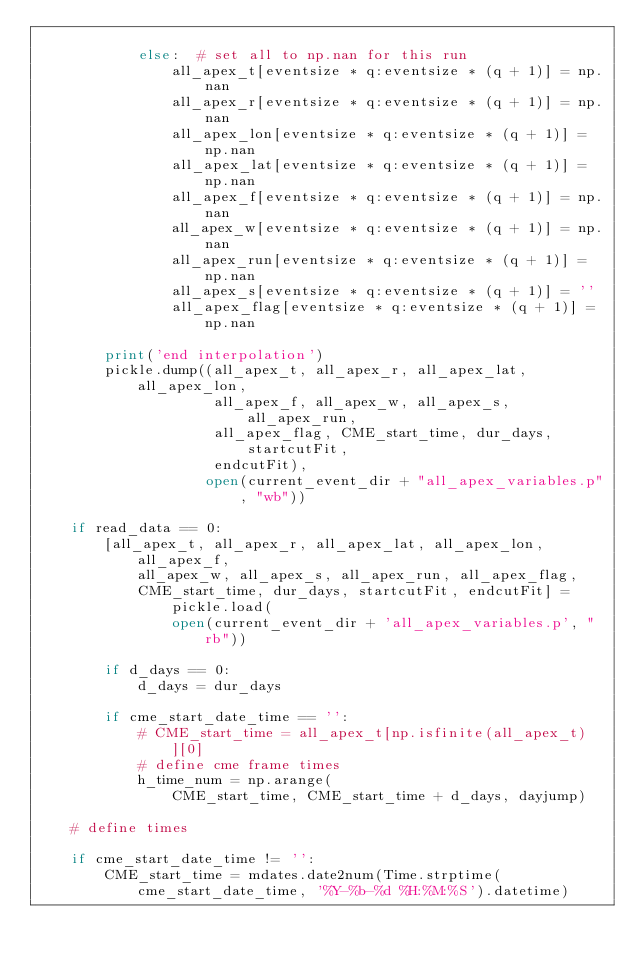<code> <loc_0><loc_0><loc_500><loc_500><_Python_>
            else:  # set all to np.nan for this run
                all_apex_t[eventsize * q:eventsize * (q + 1)] = np.nan
                all_apex_r[eventsize * q:eventsize * (q + 1)] = np.nan
                all_apex_lon[eventsize * q:eventsize * (q + 1)] = np.nan
                all_apex_lat[eventsize * q:eventsize * (q + 1)] = np.nan
                all_apex_f[eventsize * q:eventsize * (q + 1)] = np.nan
                all_apex_w[eventsize * q:eventsize * (q + 1)] = np.nan
                all_apex_run[eventsize * q:eventsize * (q + 1)] = np.nan
                all_apex_s[eventsize * q:eventsize * (q + 1)] = ''
                all_apex_flag[eventsize * q:eventsize * (q + 1)] = np.nan

        print('end interpolation')
        pickle.dump((all_apex_t, all_apex_r, all_apex_lat, all_apex_lon,
                     all_apex_f, all_apex_w, all_apex_s, all_apex_run,
                     all_apex_flag, CME_start_time, dur_days, startcutFit,
                     endcutFit),
                    open(current_event_dir + "all_apex_variables.p", "wb"))

    if read_data == 0:
        [all_apex_t, all_apex_r, all_apex_lat, all_apex_lon, all_apex_f,
            all_apex_w, all_apex_s, all_apex_run, all_apex_flag,
            CME_start_time, dur_days, startcutFit, endcutFit] = pickle.load(
                open(current_event_dir + 'all_apex_variables.p', "rb"))

        if d_days == 0:
            d_days = dur_days

        if cme_start_date_time == '':
            # CME_start_time = all_apex_t[np.isfinite(all_apex_t)][0]
            # define cme frame times
            h_time_num = np.arange(
                CME_start_time, CME_start_time + d_days, dayjump)

    # define times

    if cme_start_date_time != '':
        CME_start_time = mdates.date2num(Time.strptime(
            cme_start_date_time, '%Y-%b-%d %H:%M:%S').datetime)</code> 